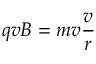<formula> <loc_0><loc_0><loc_500><loc_500>q v B = m v { \frac { v } { r } }</formula> 